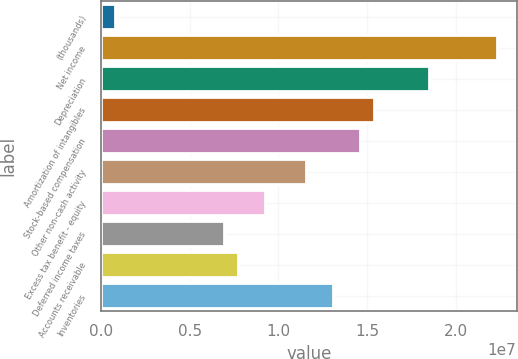Convert chart. <chart><loc_0><loc_0><loc_500><loc_500><bar_chart><fcel>(thousands)<fcel>Net income<fcel>Depreciation<fcel>Amortization of intangibles<fcel>Stock-based compensation<fcel>Other non-cash activity<fcel>Excess tax benefit - equity<fcel>Deferred income taxes<fcel>Accounts receivable<fcel>Inventories<nl><fcel>770994<fcel>2.23194e+07<fcel>1.84715e+07<fcel>1.53931e+07<fcel>1.46235e+07<fcel>1.15452e+07<fcel>9.23643e+06<fcel>6.92767e+06<fcel>7.69726e+06<fcel>1.30844e+07<nl></chart> 